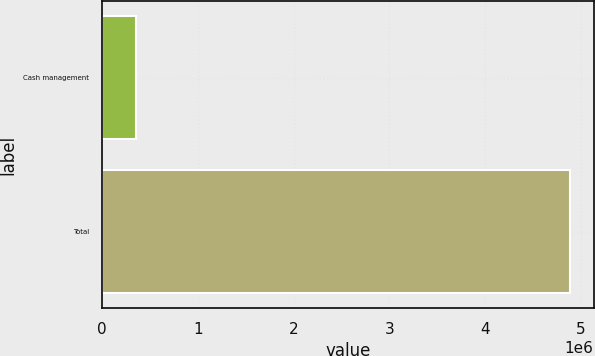Convert chart to OTSL. <chart><loc_0><loc_0><loc_500><loc_500><bar_chart><fcel>Cash management<fcel>Total<nl><fcel>358498<fcel>4.88509e+06<nl></chart> 